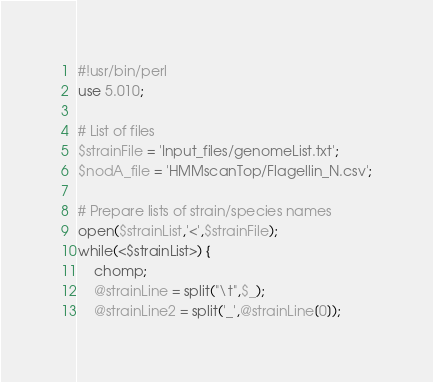<code> <loc_0><loc_0><loc_500><loc_500><_Perl_>#!usr/bin/perl
use 5.010;

# List of files
$strainFile = 'Input_files/genomeList.txt';
$nodA_file = 'HMMscanTop/Flagellin_N.csv';

# Prepare lists of strain/species names
open($strainList,'<',$strainFile);
while(<$strainList>) {
	chomp;
	@strainLine = split("\t",$_);
	@strainLine2 = split('_',@strainLine[0]);</code> 